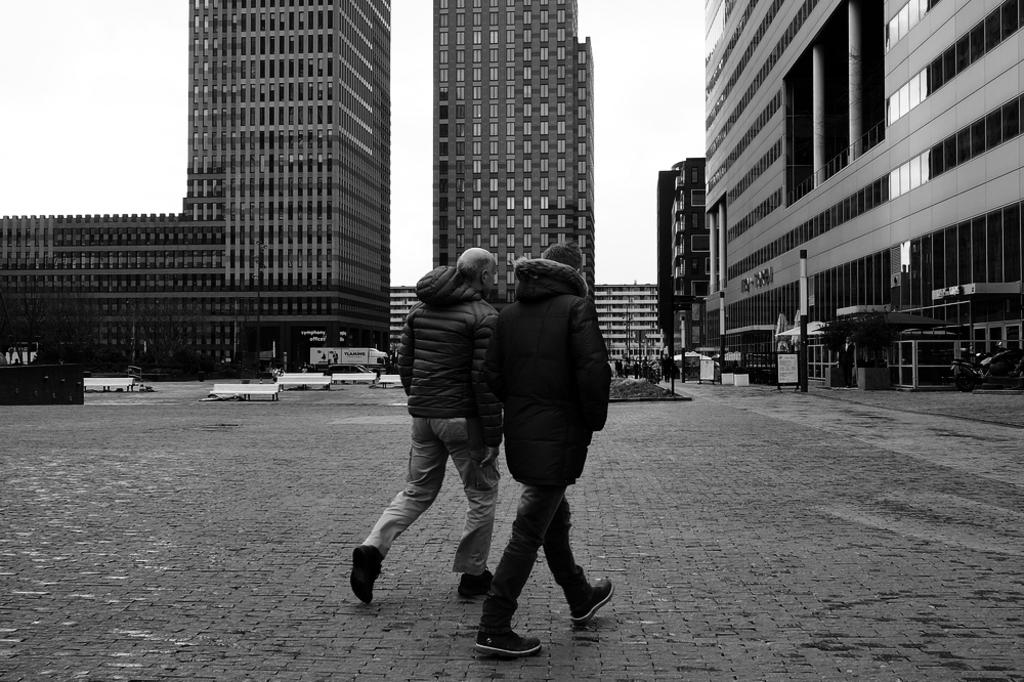What is the color scheme of the image? The image is black and white. What type of structures can be seen in the image? There are buildings in the image. What part of the natural environment is visible in the image? The sky and trees are visible in the image. What man-made objects are present in the image? There are poles in the image. Are there any people in the image? Yes, there are people in the image. What are the two people walking in the front of the image wearing? The two people walking in the front of the image are wearing jackets. Can you tell me how many bars of soap are visible in the image? There are no bars of soap present in the image. What type of land can be seen in the image? The image does not show any specific type of land; it features buildings, trees, and people. 